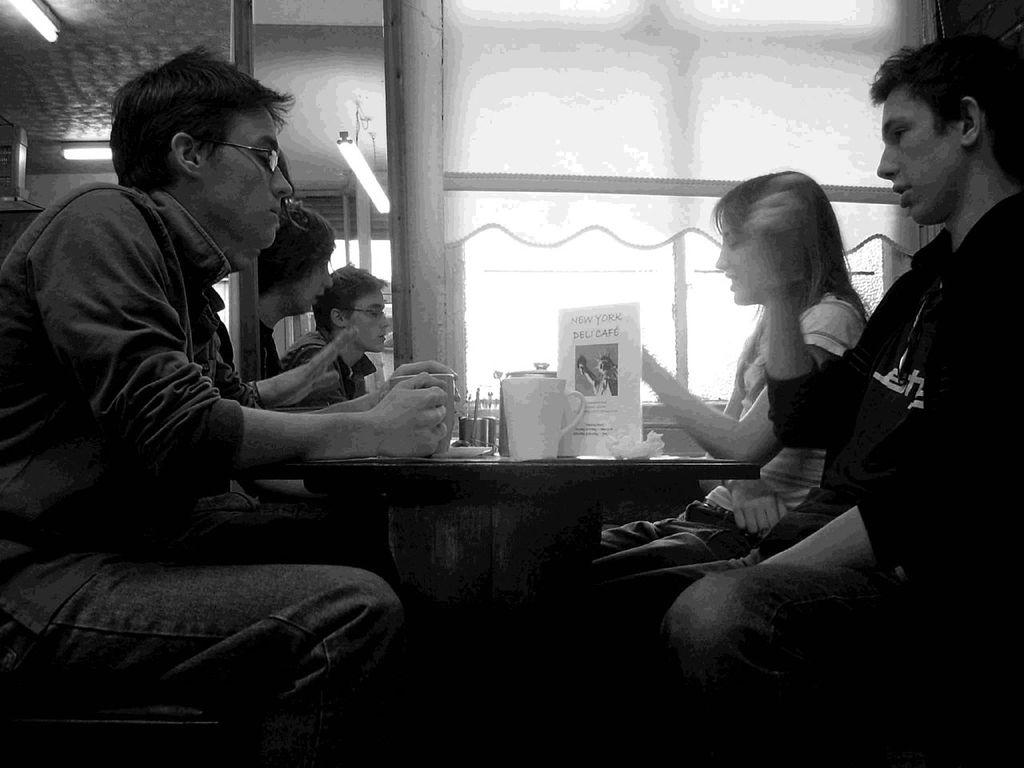How many people are in the image? There are four people in the image. Can you describe the gender of the people in the image? Three of the people are men, and one is a woman. Where are the people located in the image? The people are sitting in front of a table. What is on the table in the image? There is a cup on the table. What can be seen in the background of the image? There are windows in the background, and there is a curtain associated with the windows. What type of food is being prepared in the scene depicted in the image? There is no scene of food preparation in the image; it features four people sitting at a table with a cup. 